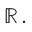Convert formula to latex. <formula><loc_0><loc_0><loc_500><loc_500>\mathbb { R } \, .</formula> 